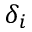<formula> <loc_0><loc_0><loc_500><loc_500>\delta _ { i }</formula> 